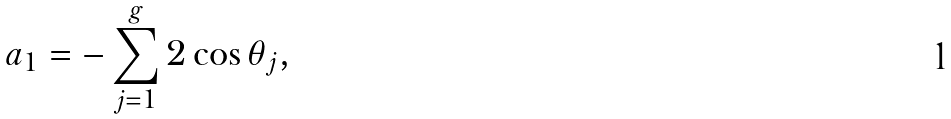Convert formula to latex. <formula><loc_0><loc_0><loc_500><loc_500>a _ { 1 } = - \sum _ { j = 1 } ^ { g } 2 \cos \theta _ { j } ,</formula> 